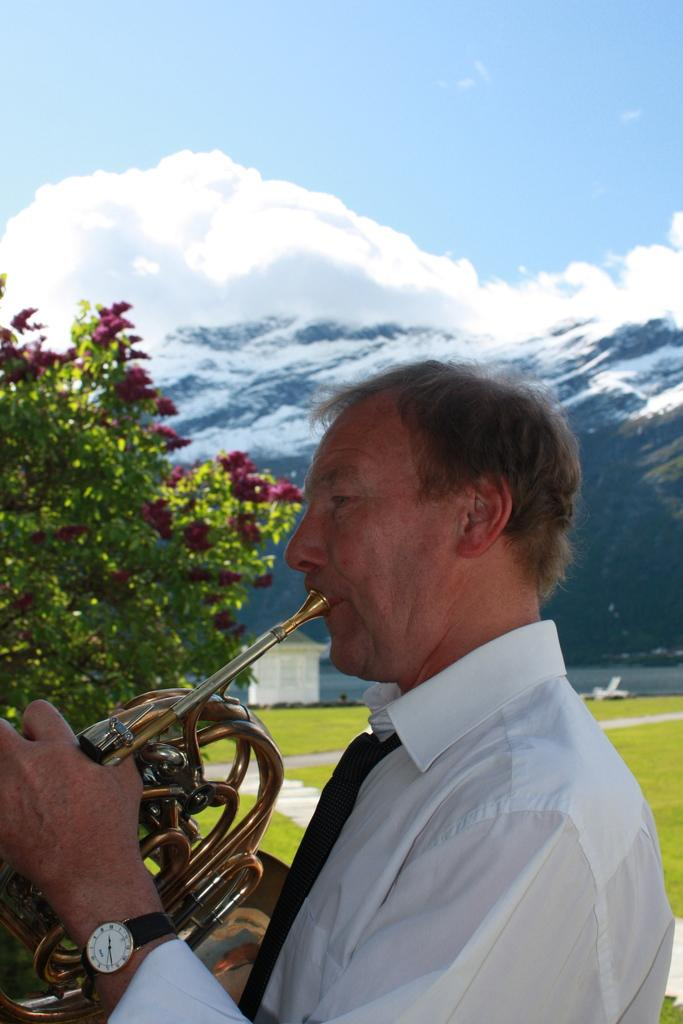What is the man in the image doing? The man is playing the Helicon in the image. What instrument is the man playing? The man is playing the Helicon, which is a type of musical instrument. What can be seen behind the man? There is a tree behind the man. What is the ground surface like behind the tree? The ground surface behind the tree is grassy. What is visible in the far background of the image? There is a mountain visible in the background. What type of game is being played by the man in the image? There is no game being played in the image; the man is playing the Helicon, which is a musical instrument. What type of plantation can be seen in the image? There is no plantation present in the image; the background features a tree, grass surface, and mountain. 